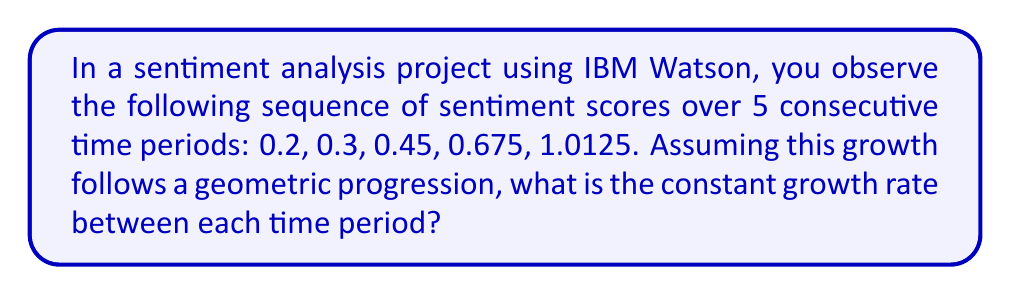Solve this math problem. To solve this problem, we need to follow these steps:

1. Recognize that this is a geometric sequence with a common ratio (growth rate) between consecutive terms.

2. Let's call the growth rate $r$. In a geometric sequence, each term is the product of the previous term and the common ratio. So we can write:

   $0.3 = 0.2 \cdot r$
   $0.45 = 0.3 \cdot r$
   $0.675 = 0.45 \cdot r$
   $1.0125 = 0.675 \cdot r$

3. We can find $r$ by dividing any term by its previous term. Let's use the first two terms:

   $$r = \frac{0.3}{0.2} = 1.5$$

4. To verify, let's check if this ratio holds for the other pairs:

   $\frac{0.45}{0.3} = 1.5$
   $\frac{0.675}{0.45} = 1.5$
   $\frac{1.0125}{0.675} = 1.5$

5. Indeed, the ratio 1.5 is consistent throughout the sequence.

6. To express this as a growth rate, we subtract 1 from the ratio and convert to a percentage:

   Growth rate = $(1.5 - 1) \cdot 100\% = 0.5 \cdot 100\% = 50\%$

Therefore, the constant growth rate between each time period is 50%.
Answer: 50% 